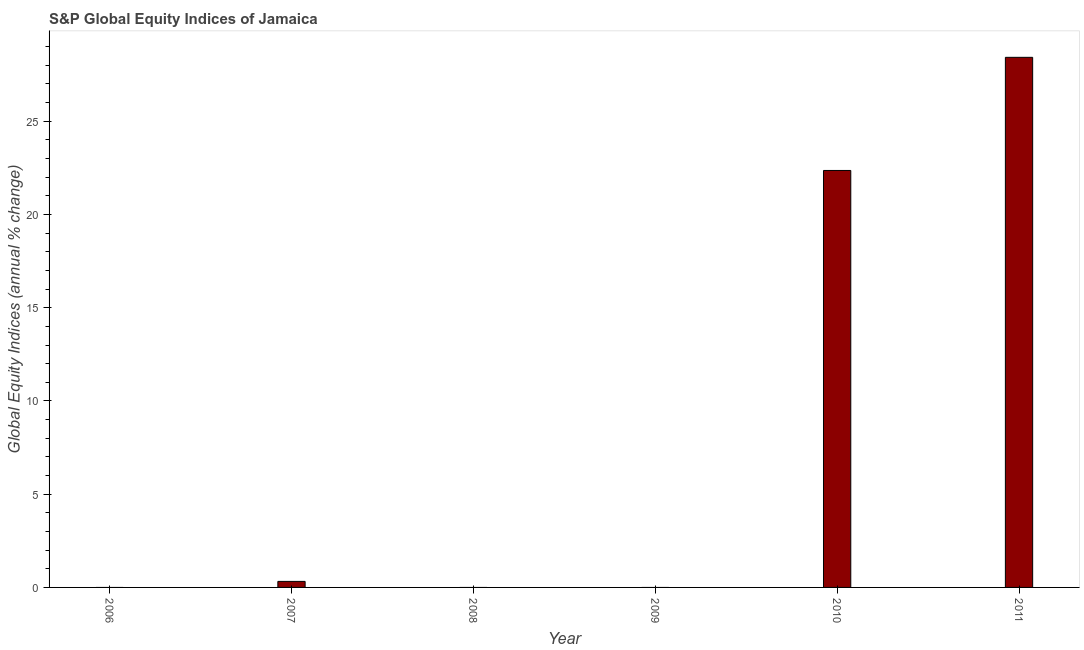Does the graph contain grids?
Keep it short and to the point. No. What is the title of the graph?
Your answer should be very brief. S&P Global Equity Indices of Jamaica. What is the label or title of the X-axis?
Keep it short and to the point. Year. What is the label or title of the Y-axis?
Your answer should be compact. Global Equity Indices (annual % change). What is the s&p global equity indices in 2010?
Give a very brief answer. 22.36. Across all years, what is the maximum s&p global equity indices?
Ensure brevity in your answer.  28.43. Across all years, what is the minimum s&p global equity indices?
Keep it short and to the point. 0. What is the sum of the s&p global equity indices?
Offer a terse response. 51.11. What is the difference between the s&p global equity indices in 2010 and 2011?
Your answer should be compact. -6.07. What is the average s&p global equity indices per year?
Ensure brevity in your answer.  8.52. What is the median s&p global equity indices?
Your answer should be very brief. 0.16. What is the ratio of the s&p global equity indices in 2010 to that in 2011?
Your answer should be very brief. 0.79. Is the s&p global equity indices in 2007 less than that in 2011?
Your response must be concise. Yes. What is the difference between the highest and the second highest s&p global equity indices?
Provide a succinct answer. 6.07. Is the sum of the s&p global equity indices in 2007 and 2011 greater than the maximum s&p global equity indices across all years?
Offer a very short reply. Yes. What is the difference between the highest and the lowest s&p global equity indices?
Your response must be concise. 28.43. How many bars are there?
Offer a very short reply. 3. How many years are there in the graph?
Offer a very short reply. 6. What is the Global Equity Indices (annual % change) of 2006?
Your response must be concise. 0. What is the Global Equity Indices (annual % change) in 2007?
Make the answer very short. 0.32. What is the Global Equity Indices (annual % change) of 2009?
Provide a short and direct response. 0. What is the Global Equity Indices (annual % change) in 2010?
Give a very brief answer. 22.36. What is the Global Equity Indices (annual % change) in 2011?
Offer a very short reply. 28.43. What is the difference between the Global Equity Indices (annual % change) in 2007 and 2010?
Provide a short and direct response. -22.04. What is the difference between the Global Equity Indices (annual % change) in 2007 and 2011?
Offer a terse response. -28.11. What is the difference between the Global Equity Indices (annual % change) in 2010 and 2011?
Keep it short and to the point. -6.07. What is the ratio of the Global Equity Indices (annual % change) in 2007 to that in 2010?
Keep it short and to the point. 0.01. What is the ratio of the Global Equity Indices (annual % change) in 2007 to that in 2011?
Your answer should be compact. 0.01. What is the ratio of the Global Equity Indices (annual % change) in 2010 to that in 2011?
Your answer should be compact. 0.79. 